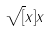<formula> <loc_0><loc_0><loc_500><loc_500>\sqrt { [ } x ] { x }</formula> 